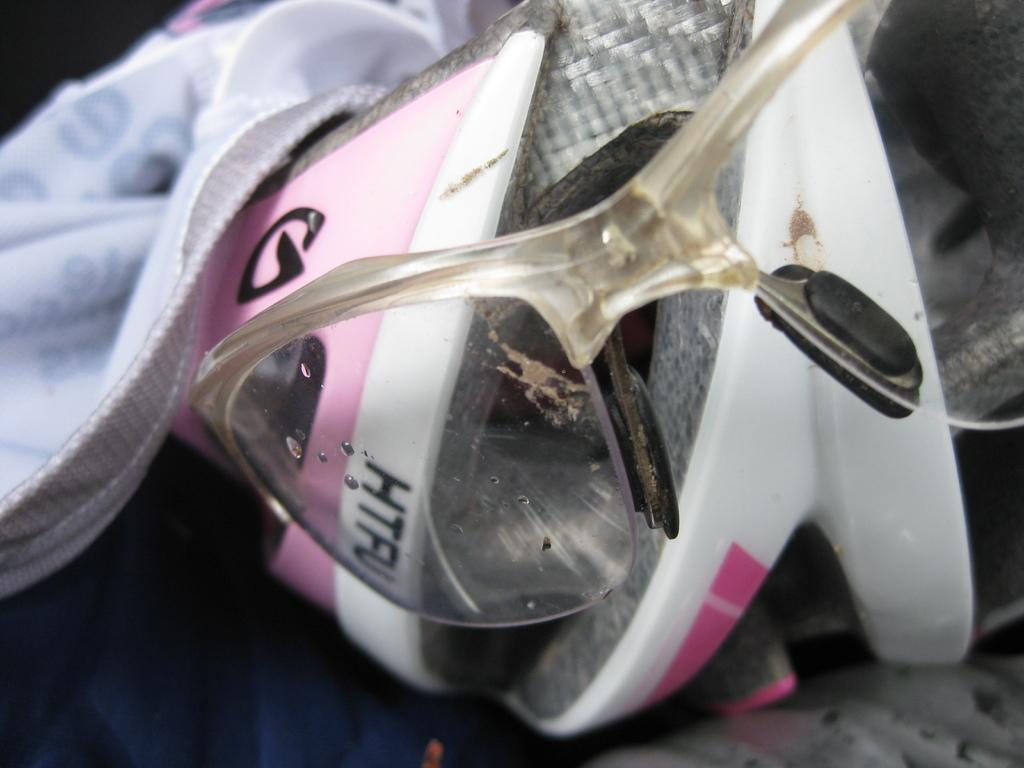What type of protective gear is visible in the image? There are goggles and a helmet in the image. What type of clothing is also visible in the image? There is a jacket in the image. What type of room is depicted in the image? There is no room visible in the image; it only shows goggles, a helmet, and a jacket. 